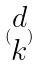Convert formula to latex. <formula><loc_0><loc_0><loc_500><loc_500>( \begin{matrix} d \\ k \end{matrix} )</formula> 